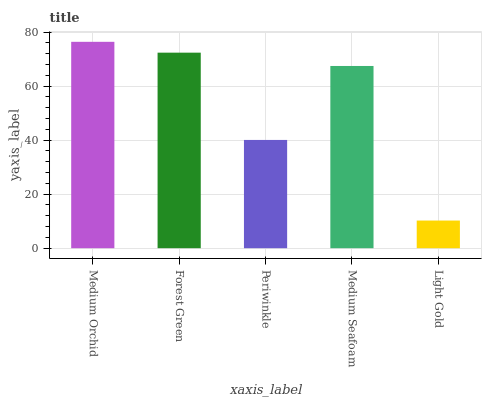Is Light Gold the minimum?
Answer yes or no. Yes. Is Medium Orchid the maximum?
Answer yes or no. Yes. Is Forest Green the minimum?
Answer yes or no. No. Is Forest Green the maximum?
Answer yes or no. No. Is Medium Orchid greater than Forest Green?
Answer yes or no. Yes. Is Forest Green less than Medium Orchid?
Answer yes or no. Yes. Is Forest Green greater than Medium Orchid?
Answer yes or no. No. Is Medium Orchid less than Forest Green?
Answer yes or no. No. Is Medium Seafoam the high median?
Answer yes or no. Yes. Is Medium Seafoam the low median?
Answer yes or no. Yes. Is Medium Orchid the high median?
Answer yes or no. No. Is Periwinkle the low median?
Answer yes or no. No. 